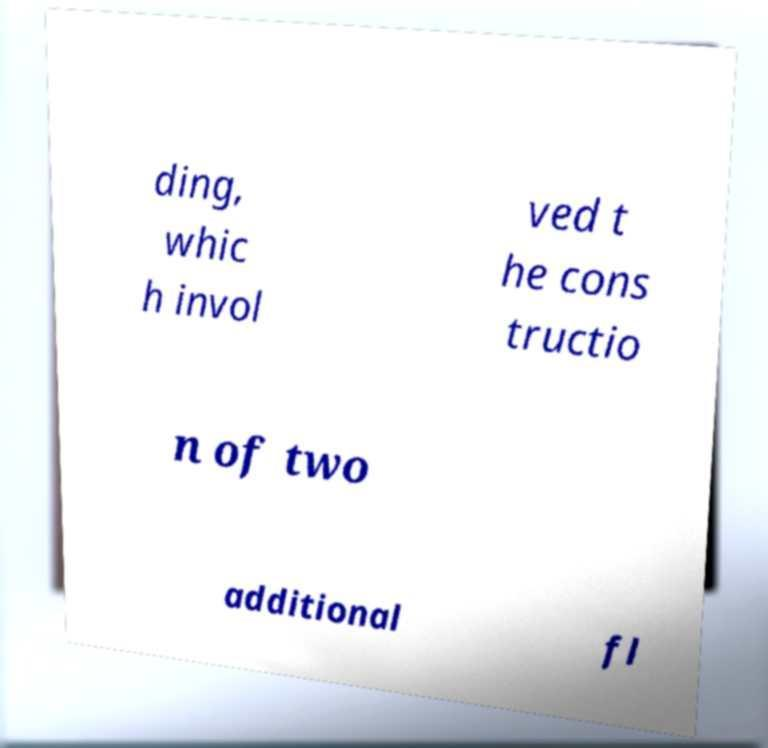Please identify and transcribe the text found in this image. ding, whic h invol ved t he cons tructio n of two additional fl 